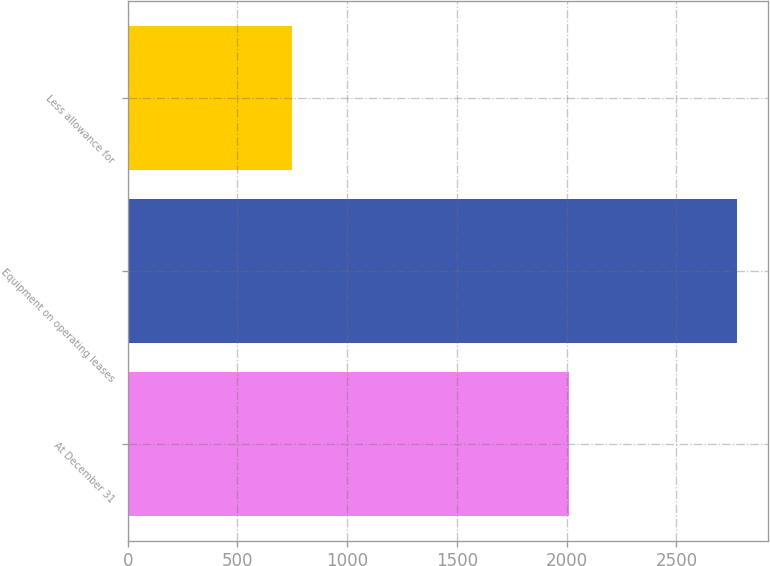<chart> <loc_0><loc_0><loc_500><loc_500><bar_chart><fcel>At December 31<fcel>Equipment on operating leases<fcel>Less allowance for<nl><fcel>2012<fcel>2778.2<fcel>747.4<nl></chart> 